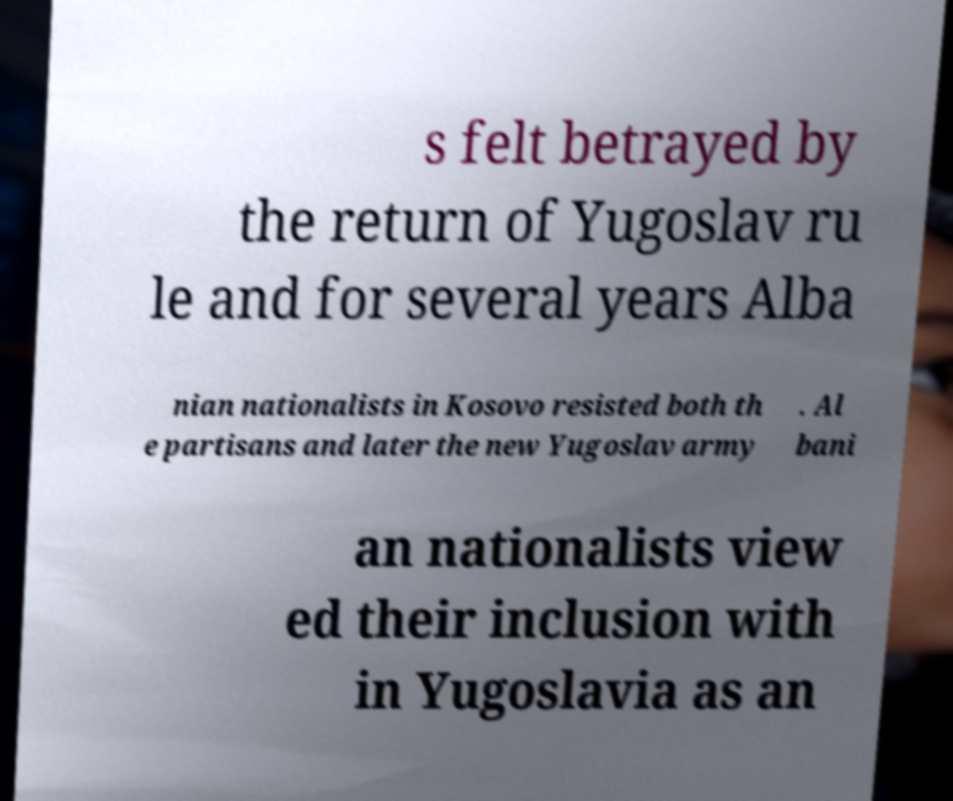Could you assist in decoding the text presented in this image and type it out clearly? s felt betrayed by the return of Yugoslav ru le and for several years Alba nian nationalists in Kosovo resisted both th e partisans and later the new Yugoslav army . Al bani an nationalists view ed their inclusion with in Yugoslavia as an 